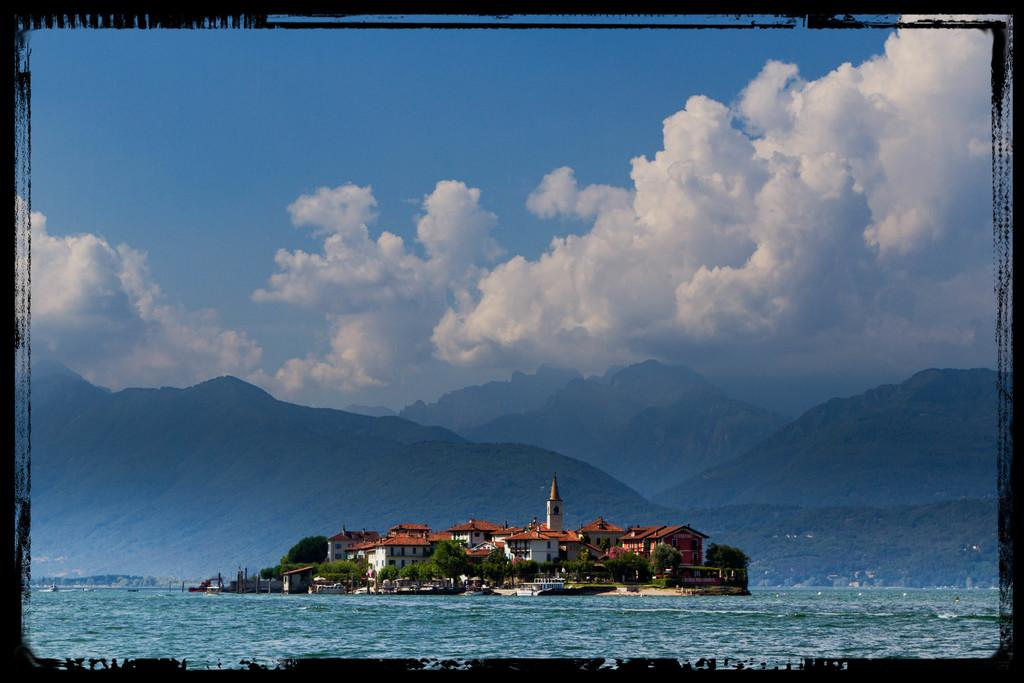What is the primary element visible in the image? There is water in the image. What type of structure can be seen in the image? There is a tower in the image. What type of buildings are present in the image? There are houses in the image. What type of vegetation is present in the image? There are trees in the image. What else can be seen in the image besides the water, tower, houses, and trees? There are objects in the image. What can be seen in the background of the image? There are mountains and sky visible in the background of the image. What is the condition of the sky in the image? There are clouds in the sky. Can you see any fog in the image? There is no fog present in the image. Is there a cave visible in the image? There is no cave present in the image. 